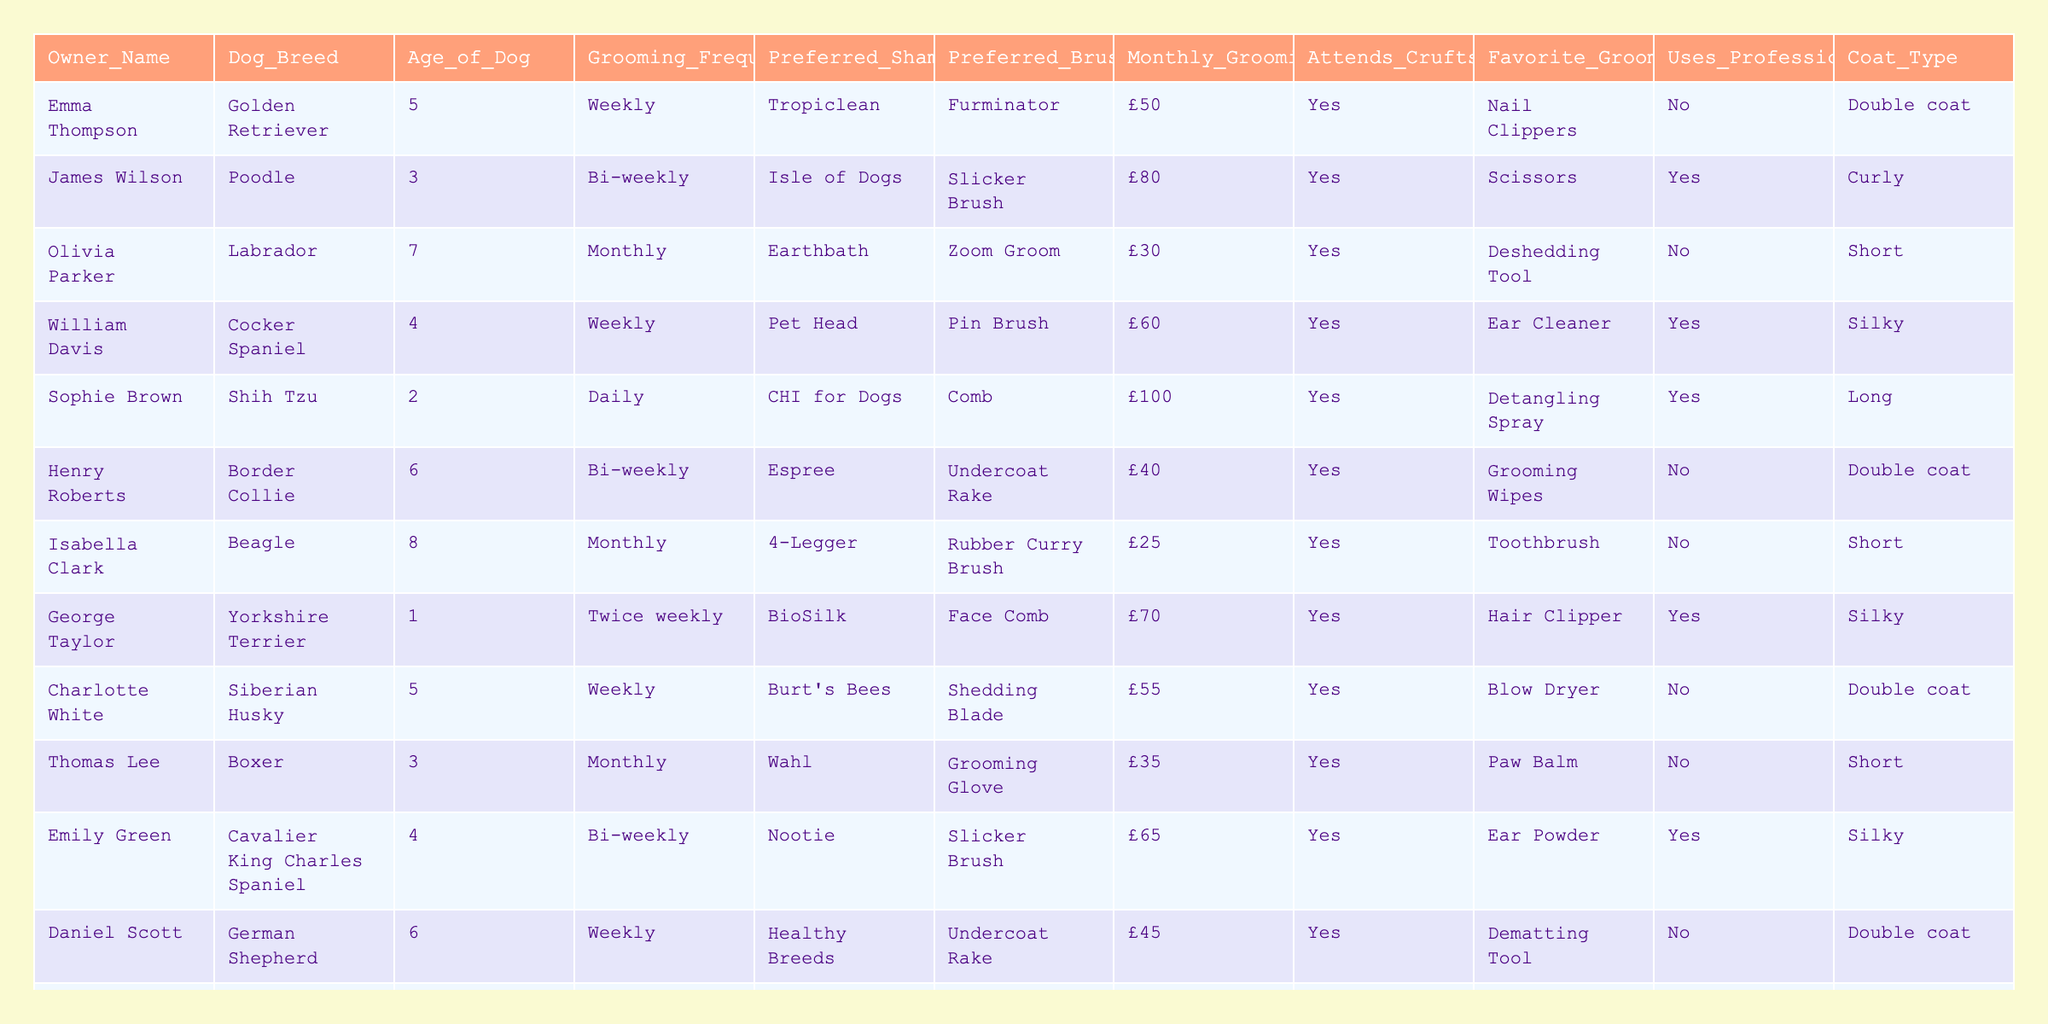What is the most common grooming frequency among the dog owners? By reviewing the "Grooming Frequency" column, we can observe the listed frequencies: Weekly, Bi-weekly, Monthly, Daily, and Twice weekly. The majority of the entries indicate Weekly grooming (Emma, William, Charlotte, Daniel, and Michael have this frequency), making it the most common choice.
Answer: Weekly How many dog owners prefer Tropiclean shampoo? Looking at the "Preferred Shampoo" column, we can find instances of Tropiclean. Emma and Ava both indicated they use Tropiclean, totaling two owners.
Answer: 2 What is the average monthly grooming budget of the respondents? To calculate the average monthly grooming budget, we sum the budgets: £50 + £80 + £30 + £60 + £100 + £40 + £25 + £70 + £55 + £35 + £65 + £45 + £40 + £50 + £90 = £730. There are 15 owners, so the average is £730 / 15 = £48.67.
Answer: £48.67 Do any of the owners use a professional groomer? By checking the "Uses Professional Groomer" column, we can see that there are owners who answered "Yes" (James, William, Sophie, Emily) and some who answered "No." Therefore, the statement is true.
Answer: Yes What is the relationship between grooming frequency and the use of professional groomers? First, we observe that those who groom their dogs weekly or daily tend to not use professional groomers, while bi-weekly and monthly groomers mostly do hire professionals. This indicates that more frequent groomers prefer to handle grooming themselves.
Answer: More frequent groomers generally do not use professionals Which dog breed has the highest monthly grooming budget and what is that budget? The dog breeds and their budgets are: Golden Retriever £50, Poodle £80, Labrador £30, Cocker Spaniel £60, Shih Tzu £100, Border Collie £40, Beagle £25, Yorkshire Terrier £70, Siberian Husky £55, Boxer £35, Cavalier King Charles Spaniel £65, German Shepherd £45, Chihuahua £40, Shetland Sheepdog £50, and Bichon Frise £90. The highest budget is from the Shih Tzu at £100.
Answer: Shih Tzu, £100 Is there a dog owner who grooms their dog daily and attends Crufts? Analyzing the "Grooming Frequency" and "Attends Crufts" columns, we find that Sophie Brown grooms her dog daily and also indicates she attends Crufts. Thus, the statement is true.
Answer: Yes What percentage of dog owners in the survey prefer Slicker Brushes? From the "Preferred Brush" column, there are three owners that prefer Slicker Brushes (James, Emily, Sophia) out of 15 total owners. Thus, the percentage is (3/15) * 100 = 20%.
Answer: 20% How many different coat types are represented in the survey data? Checking the "Coat Type" column, we see that there are 4 unique types: Double coat, Curly, Short, and Silky. Thus, there are four different coat types.
Answer: 4 What is the average age of the dogs owned by the respondents? We sum the dog's ages: 5 + 3 + 7 + 4 + 2 + 6 + 8 + 1 + 5 + 3 + 4 + 6 + 2 + 7 + 3 = 70. Then, by dividing by the number of owners (15), we find the average age is 70 / 15 = 4.67 years.
Answer: 4.67 years Are there any owners who have a grooming budget of less than £30? By checking the "Monthly Grooming Budget" column, the minimum budget listed is £25 (from Isabella Clark). Therefore, the answer to the question is true.
Answer: Yes 